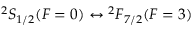<formula> <loc_0><loc_0><loc_500><loc_500>{ } ^ { 2 } S _ { 1 / 2 } ( F = 0 ) ^ { 2 } F _ { 7 / 2 } ( F = 3 )</formula> 